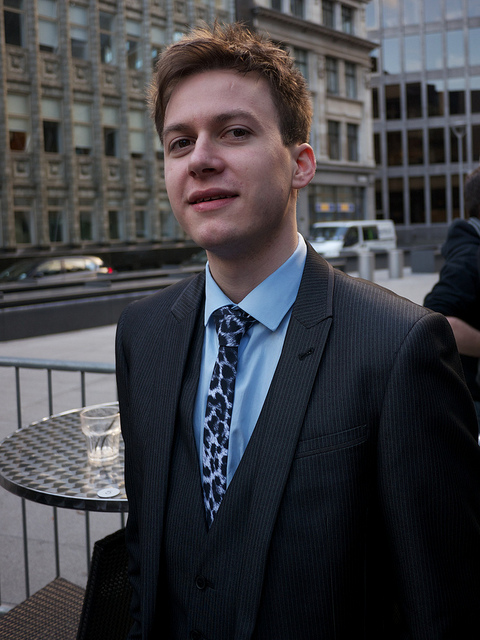<image>Do they work for the same company? It's ambiguous whether they work for the same company or not. Do they work for the same company? I don't know if they work for the same company. It seems that some say 'yes' and some say 'no'. 